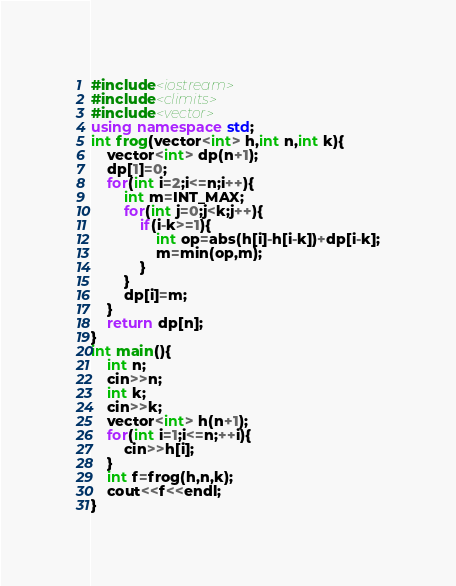Convert code to text. <code><loc_0><loc_0><loc_500><loc_500><_C++_>#include<iostream>
#include<climits>
#include<vector>
using namespace std;
int frog(vector<int> h,int n,int k){
    vector<int> dp(n+1);
    dp[1]=0;
    for(int i=2;i<=n;i++){
        int m=INT_MAX;
        for(int j=0;j<k;j++){
            if(i-k>=1){
                int op=abs(h[i]-h[i-k])+dp[i-k];
                m=min(op,m);
            }
        }
        dp[i]=m;
    }
    return dp[n];
}
int main(){
    int n;
    cin>>n;
    int k;
    cin>>k;
    vector<int> h(n+1);
    for(int i=1;i<=n;++i){
        cin>>h[i];
    }
    int f=frog(h,n,k);
    cout<<f<<endl;
}
</code> 